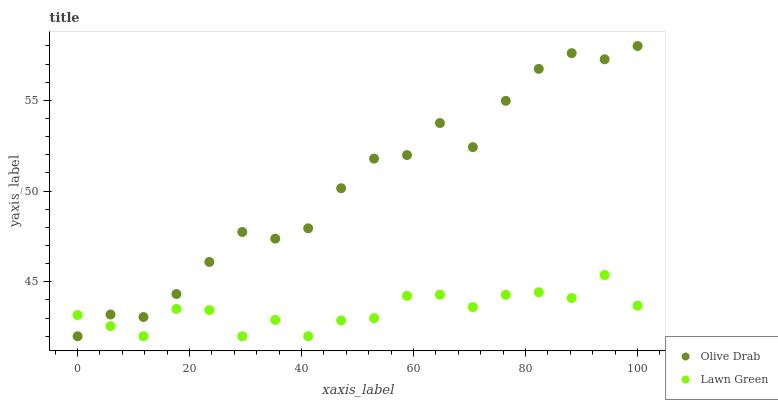Does Lawn Green have the minimum area under the curve?
Answer yes or no. Yes. Does Olive Drab have the maximum area under the curve?
Answer yes or no. Yes. Does Olive Drab have the minimum area under the curve?
Answer yes or no. No. Is Lawn Green the smoothest?
Answer yes or no. Yes. Is Olive Drab the roughest?
Answer yes or no. Yes. Is Olive Drab the smoothest?
Answer yes or no. No. Does Lawn Green have the lowest value?
Answer yes or no. Yes. Does Olive Drab have the highest value?
Answer yes or no. Yes. Does Lawn Green intersect Olive Drab?
Answer yes or no. Yes. Is Lawn Green less than Olive Drab?
Answer yes or no. No. Is Lawn Green greater than Olive Drab?
Answer yes or no. No. 